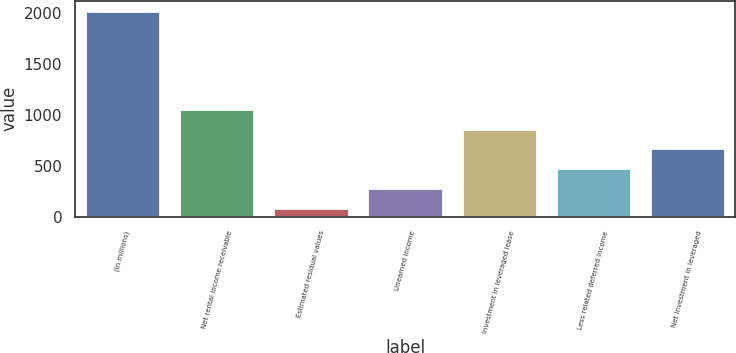Convert chart to OTSL. <chart><loc_0><loc_0><loc_500><loc_500><bar_chart><fcel>(In millions)<fcel>Net rental income receivable<fcel>Estimated residual values<fcel>Unearned income<fcel>Investment in leveraged lease<fcel>Less related deferred income<fcel>Net investment in leveraged<nl><fcel>2016<fcel>1056.8<fcel>89<fcel>286<fcel>864.1<fcel>478.7<fcel>671.4<nl></chart> 